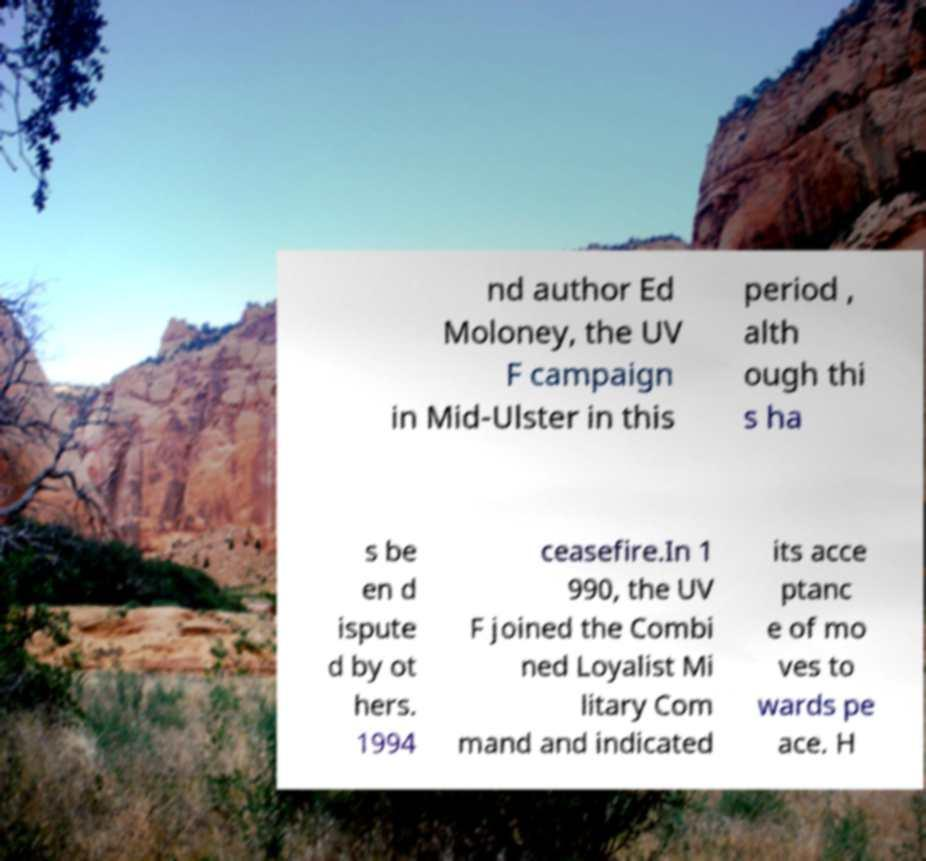I need the written content from this picture converted into text. Can you do that? nd author Ed Moloney, the UV F campaign in Mid-Ulster in this period , alth ough thi s ha s be en d ispute d by ot hers. 1994 ceasefire.In 1 990, the UV F joined the Combi ned Loyalist Mi litary Com mand and indicated its acce ptanc e of mo ves to wards pe ace. H 